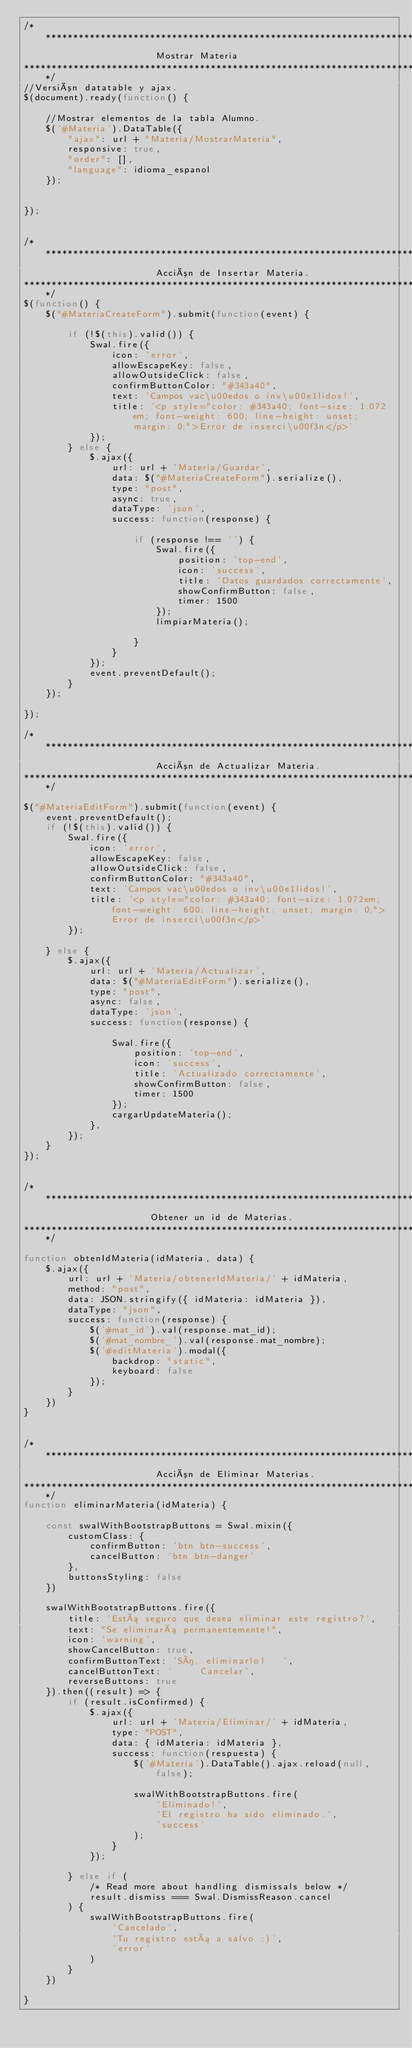<code> <loc_0><loc_0><loc_500><loc_500><_JavaScript_>/****************************************************************************
                        Mostrar Materia
****************************************************************************/
//Versión datatable y ajax.
$(document).ready(function() {

    //Mostrar elementos de la tabla Alumno.
    $('#Materia').DataTable({
        "ajax": url + "Materia/MostrarMateria",
        responsive: true,
        "order": [],
        "language": idioma_espanol
    });


});


/****************************************************************************
                        Acción de Insertar Materia.
****************************************************************************/
$(function() {
    $("#MateriaCreateForm").submit(function(event) {

        if (!$(this).valid()) {
            Swal.fire({
                icon: 'error',
                allowEscapeKey: false,
                allowOutsideClick: false,
                confirmButtonColor: "#343a40",
                text: 'Campos vac\u00edos o inv\u00e1lidos!',
                title: '<p style="color: #343a40; font-size: 1.072em; font-weight: 600; line-height: unset; margin: 0;">Error de inserci\u00f3n</p>'
            });
        } else {
            $.ajax({
                url: url + 'Materia/Guardar',
                data: $("#MateriaCreateForm").serialize(),
                type: "post",
                async: true,
                dataType: 'json',
                success: function(response) {

                    if (response !== '') {
                        Swal.fire({
                            position: 'top-end',
                            icon: 'success',
                            title: 'Datos guardados correctamente',
                            showConfirmButton: false,
                            timer: 1500
                        });
                        limpiarMateria();

                    }
                }
            });
            event.preventDefault();
        }
    });

});

/****************************************************************************
                        Acción de Actualizar Materia.
****************************************************************************/

$("#MateriaEditForm").submit(function(event) {
    event.preventDefault();
    if (!$(this).valid()) {
        Swal.fire({
            icon: 'error',
            allowEscapeKey: false,
            allowOutsideClick: false,
            confirmButtonColor: "#343a40",
            text: 'Campos vac\u00edos o inv\u00e1lidos!',
            title: '<p style="color: #343a40; font-size: 1.072em; font-weight: 600; line-height: unset; margin: 0;">Error de inserci\u00f3n</p>'
        });

    } else {
        $.ajax({
            url: url + 'Materia/Actualizar',
            data: $("#MateriaEditForm").serialize(),
            type: "post",
            async: false,
            dataType: 'json',
            success: function(response) {

                Swal.fire({
                    position: 'top-end',
                    icon: 'success',
                    title: 'Actualizado correctamente',
                    showConfirmButton: false,
                    timer: 1500
                });
                cargarUpdateMateria();
            },
        });
    }
});


/****************************************************************************
                       Obtener un id de Materias.
****************************************************************************/

function obtenIdMateria(idMateria, data) {
    $.ajax({
        url: url + 'Materia/obtenerIdMateria/' + idMateria,
        method: "post",
        data: JSON.stringify({ idMateria: idMateria }),
        dataType: "json",
        success: function(response) {
            $('#mat_id').val(response.mat_id);
            $('#mat_nombre_').val(response.mat_nombre);
            $('#editMateria').modal({
                backdrop: "static",
                keyboard: false
            });
        }
    })
}


/****************************************************************************
                        Acción de Eliminar Materias.
****************************************************************************/
function eliminarMateria(idMateria) {

    const swalWithBootstrapButtons = Swal.mixin({
        customClass: {
            confirmButton: 'btn btn-success',
            cancelButton: 'btn btn-danger'
        },
        buttonsStyling: false
    })

    swalWithBootstrapButtons.fire({
        title: 'Está seguro que desea eliminar este registro?',
        text: "Se eliminará permanentemente!",
        icon: 'warning',
        showCancelButton: true,
        confirmButtonText: 'Sí, eliminarlo!   ',
        cancelButtonText: '     Cancelar',
        reverseButtons: true
    }).then((result) => {
        if (result.isConfirmed) {
            $.ajax({
                url: url + 'Materia/Eliminar/' + idMateria,
                type: "POST",
                data: { idMateria: idMateria },
                success: function(respuesta) {
                    $('#Materia').DataTable().ajax.reload(null, false);

                    swalWithBootstrapButtons.fire(
                        'Eliminado!',
                        'El registro ha sido eliminado.',
                        'success'
                    );
                }
            });

        } else if (
            /* Read more about handling dismissals below */
            result.dismiss === Swal.DismissReason.cancel
        ) {
            swalWithBootstrapButtons.fire(
                'Cancelado',
                'Tu registro está a salvo :)',
                'error'
            )
        }
    })

}</code> 